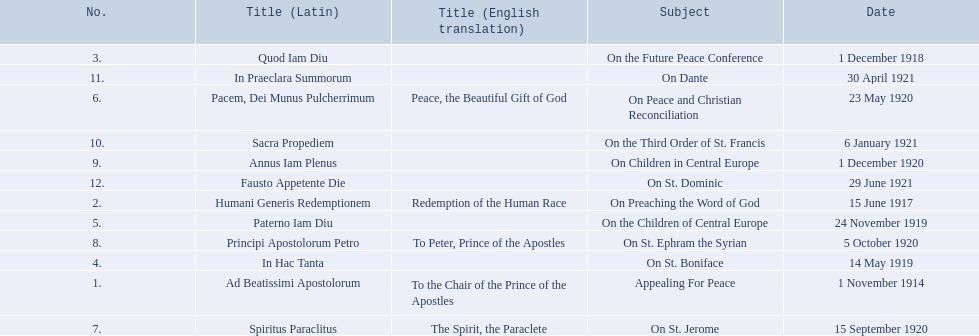What are all the subjects? Appealing For Peace, On Preaching the Word of God, On the Future Peace Conference, On St. Boniface, On the Children of Central Europe, On Peace and Christian Reconciliation, On St. Jerome, On St. Ephram the Syrian, On Children in Central Europe, On the Third Order of St. Francis, On Dante, On St. Dominic. What are their dates? 1 November 1914, 15 June 1917, 1 December 1918, 14 May 1919, 24 November 1919, 23 May 1920, 15 September 1920, 5 October 1920, 1 December 1920, 6 January 1921, 30 April 1921, 29 June 1921. Which subject's date belongs to 23 may 1920? On Peace and Christian Reconciliation. 